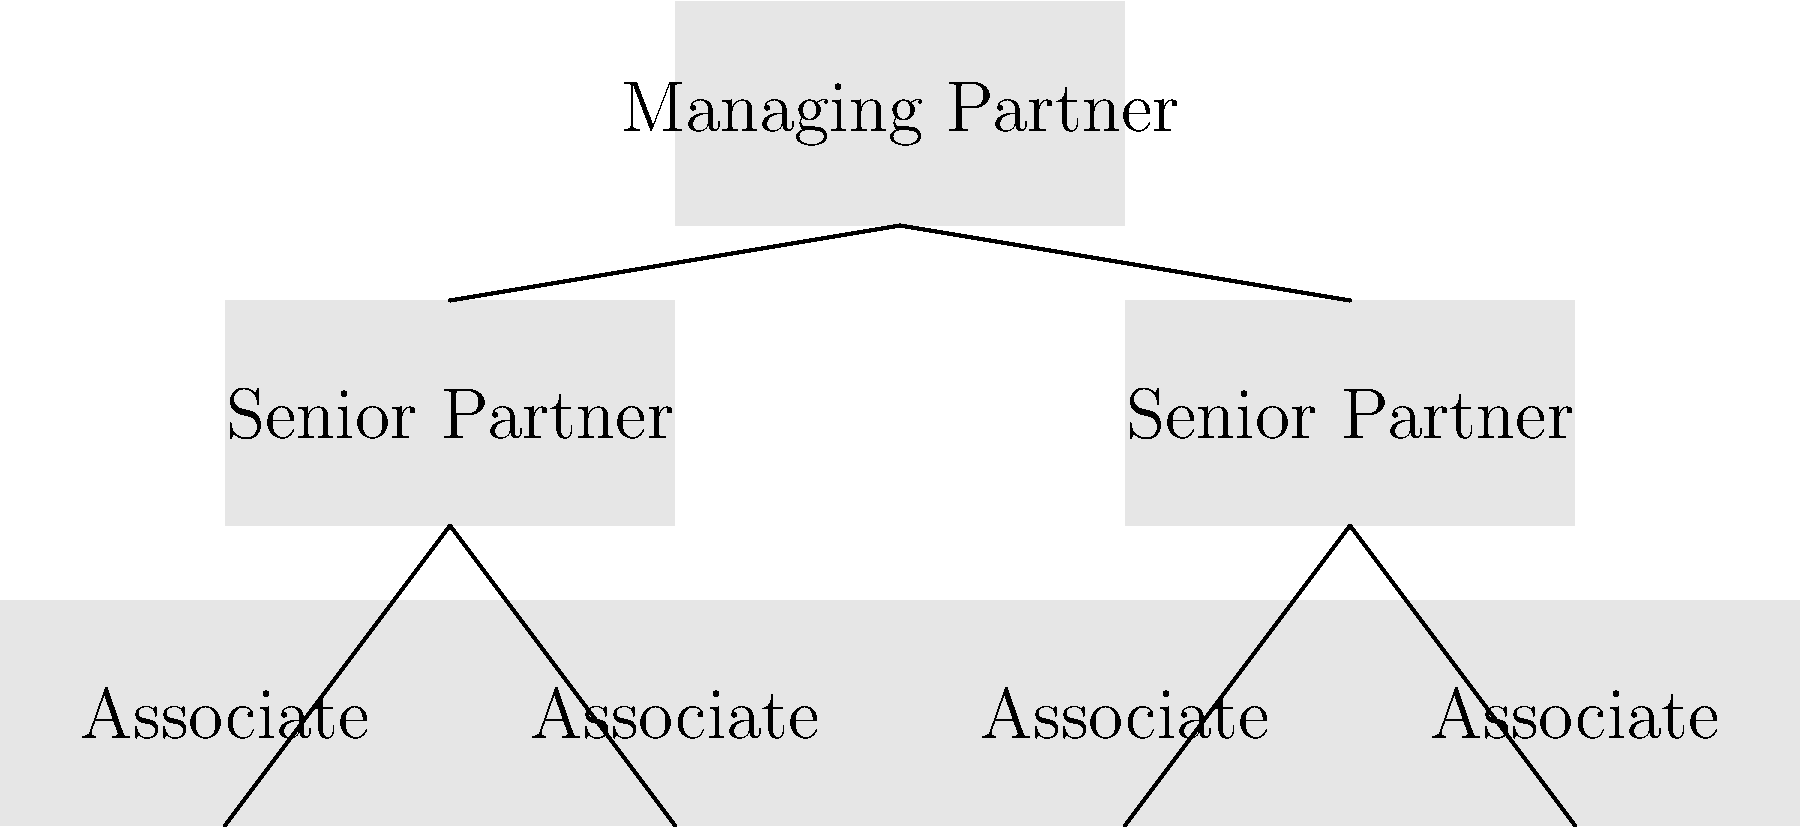In the organizational chart of Arnold Law Office, how many levels of hierarchy are present, and what does this structure suggest about the firm's management approach? To answer this question, let's analyze the organizational chart step-by-step:

1. Identify the levels:
   a) Top level: Managing Partner
   b) Middle level: Senior Partners
   c) Bottom level: Associates

2. Count the levels:
   There are 3 distinct levels in the hierarchy.

3. Analyze the structure:
   a) The Managing Partner is at the top, overseeing the entire firm.
   b) Two Senior Partners report directly to the Managing Partner.
   c) Four Associates are divided equally under the two Senior Partners.

4. Interpret the management approach:
   a) Centralized leadership: The Managing Partner is at the top, indicating a clear chain of command.
   b) Flat hierarchy: With only three levels, the structure is relatively flat, suggesting efficient communication and decision-making.
   c) Balanced workload: Each Senior Partner oversees two Associates, indicating an even distribution of responsibilities.
   d) Clear reporting lines: Associates report to Senior Partners, who in turn report to the Managing Partner.

5. Implications for the firm:
   a) Streamlined decision-making process
   b) Potential for quick adaptability to changes
   c) Direct oversight of Associates by experienced Senior Partners
   d) Opportunity for mentorship and professional development

This structure suggests that Arnold Law Office employs a balanced approach to management, combining centralized leadership with a relatively flat hierarchy to promote efficiency and clear communication channels.
Answer: 3 levels; balanced, centralized management with streamlined decision-making 